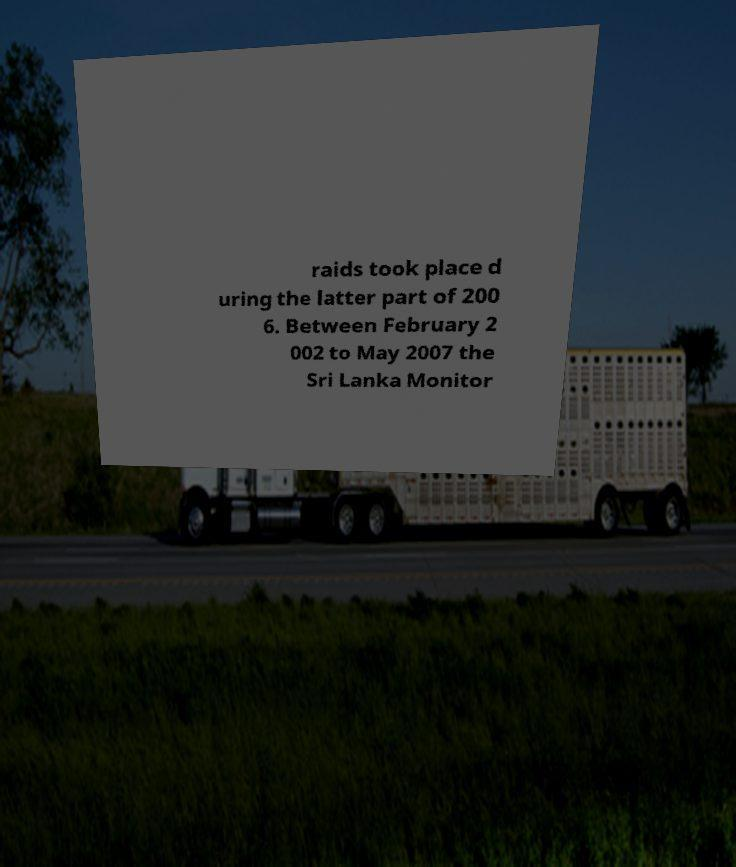I need the written content from this picture converted into text. Can you do that? raids took place d uring the latter part of 200 6. Between February 2 002 to May 2007 the Sri Lanka Monitor 